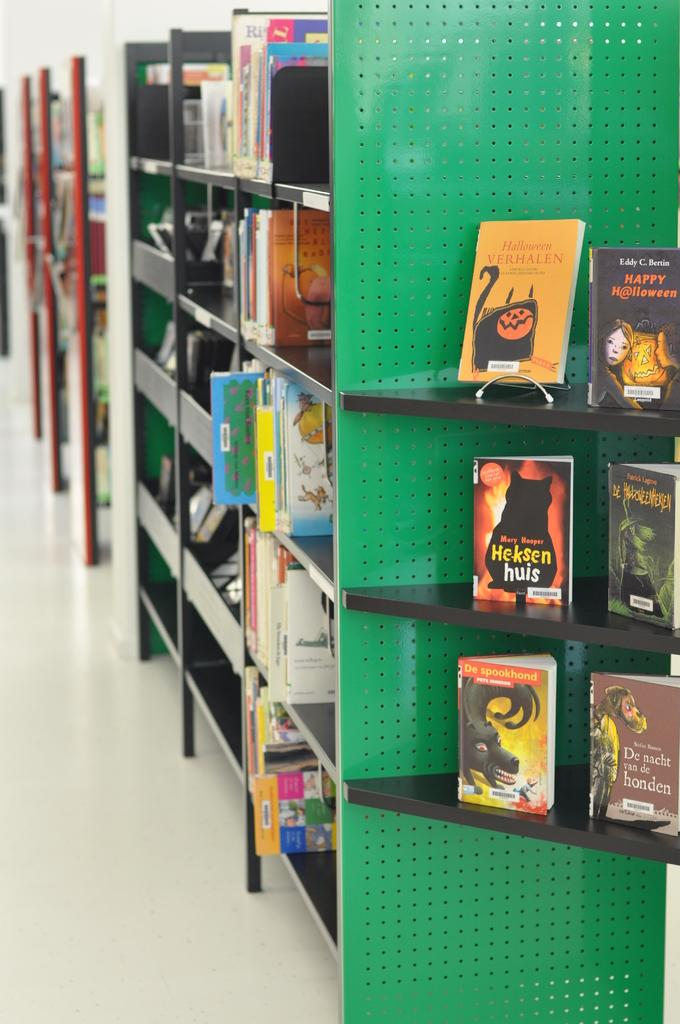Provide a one-sentence caption for the provided image. The orange book on the top shelf is called Halloween Verhalen. 